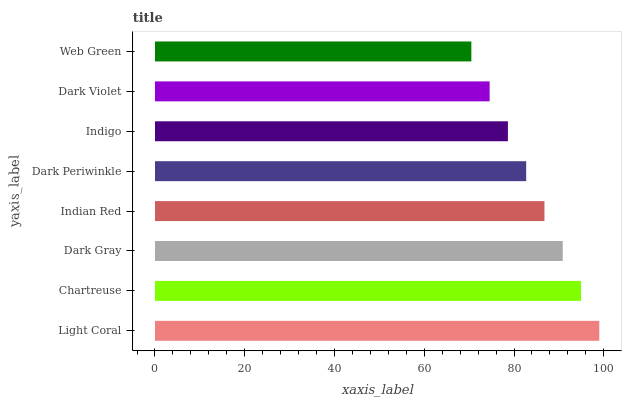Is Web Green the minimum?
Answer yes or no. Yes. Is Light Coral the maximum?
Answer yes or no. Yes. Is Chartreuse the minimum?
Answer yes or no. No. Is Chartreuse the maximum?
Answer yes or no. No. Is Light Coral greater than Chartreuse?
Answer yes or no. Yes. Is Chartreuse less than Light Coral?
Answer yes or no. Yes. Is Chartreuse greater than Light Coral?
Answer yes or no. No. Is Light Coral less than Chartreuse?
Answer yes or no. No. Is Indian Red the high median?
Answer yes or no. Yes. Is Dark Periwinkle the low median?
Answer yes or no. Yes. Is Dark Periwinkle the high median?
Answer yes or no. No. Is Chartreuse the low median?
Answer yes or no. No. 